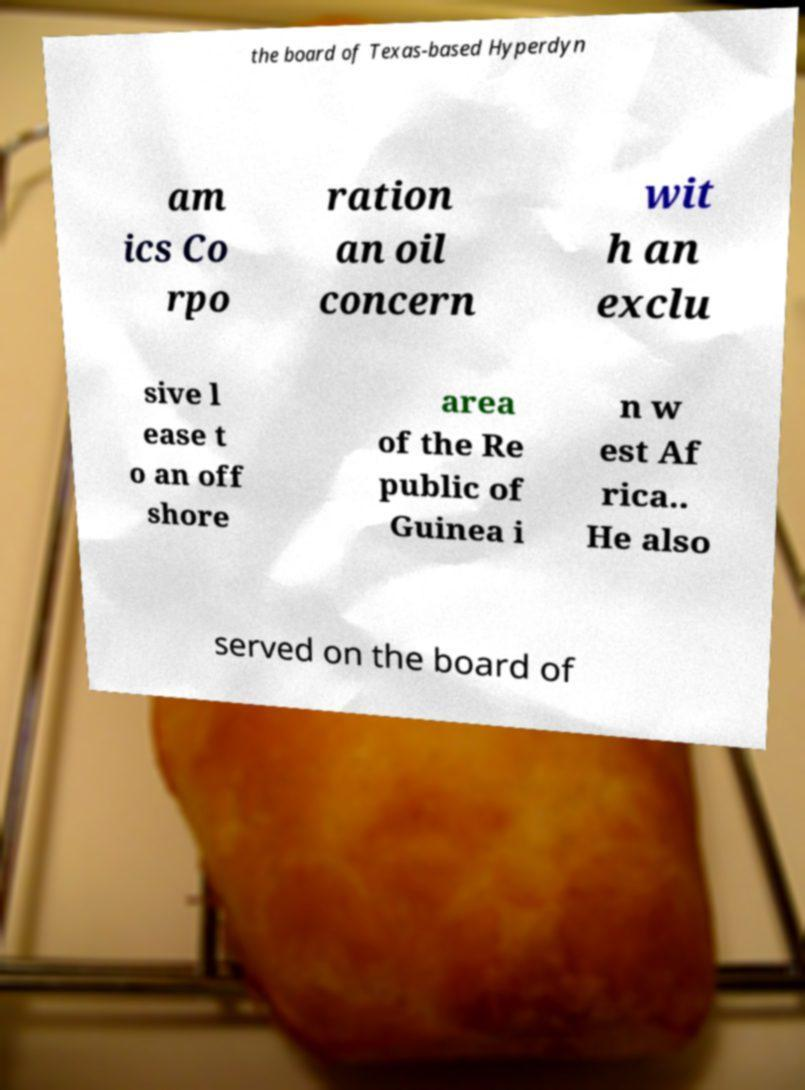Can you accurately transcribe the text from the provided image for me? the board of Texas-based Hyperdyn am ics Co rpo ration an oil concern wit h an exclu sive l ease t o an off shore area of the Re public of Guinea i n w est Af rica.. He also served on the board of 